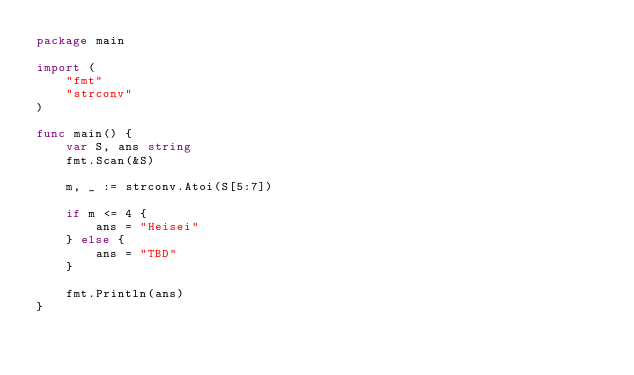Convert code to text. <code><loc_0><loc_0><loc_500><loc_500><_Go_>package main

import (
	"fmt"
	"strconv"
)

func main() {
	var S, ans string
	fmt.Scan(&S)

	m, _ := strconv.Atoi(S[5:7])

	if m <= 4 {
		ans = "Heisei"
	} else {
		ans = "TBD"
	}

	fmt.Println(ans)
}
</code> 